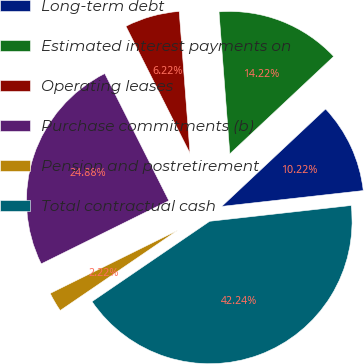<chart> <loc_0><loc_0><loc_500><loc_500><pie_chart><fcel>Long-term debt<fcel>Estimated interest payments on<fcel>Operating leases<fcel>Purchase commitments (b)<fcel>Pension and postretirement<fcel>Total contractual cash<nl><fcel>10.22%<fcel>14.22%<fcel>6.22%<fcel>24.88%<fcel>2.22%<fcel>42.24%<nl></chart> 